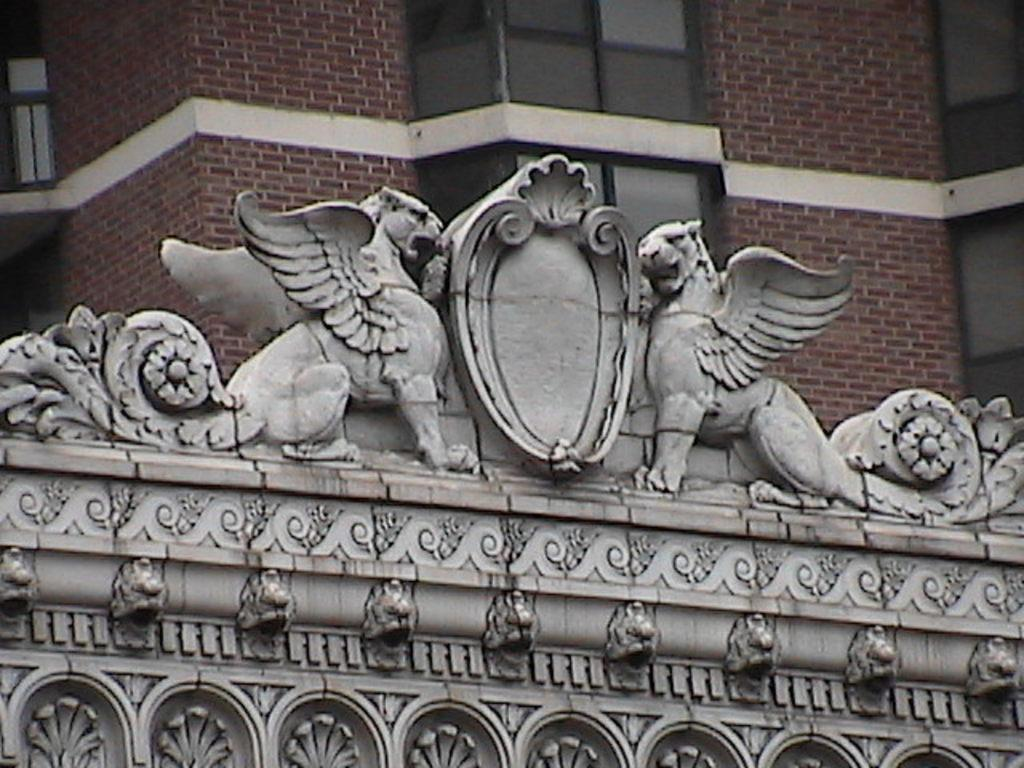What is the main subject in the image? There is a stone carving in the image. Can you describe the background of the image? There is a building with windows behind the stone carving. What type of cast can be seen working on the stone carving in the image? There is no cast or person working on the stone carving in the image; it is a static carving. What is the pail used for in the image? There is no pail present in the image. 